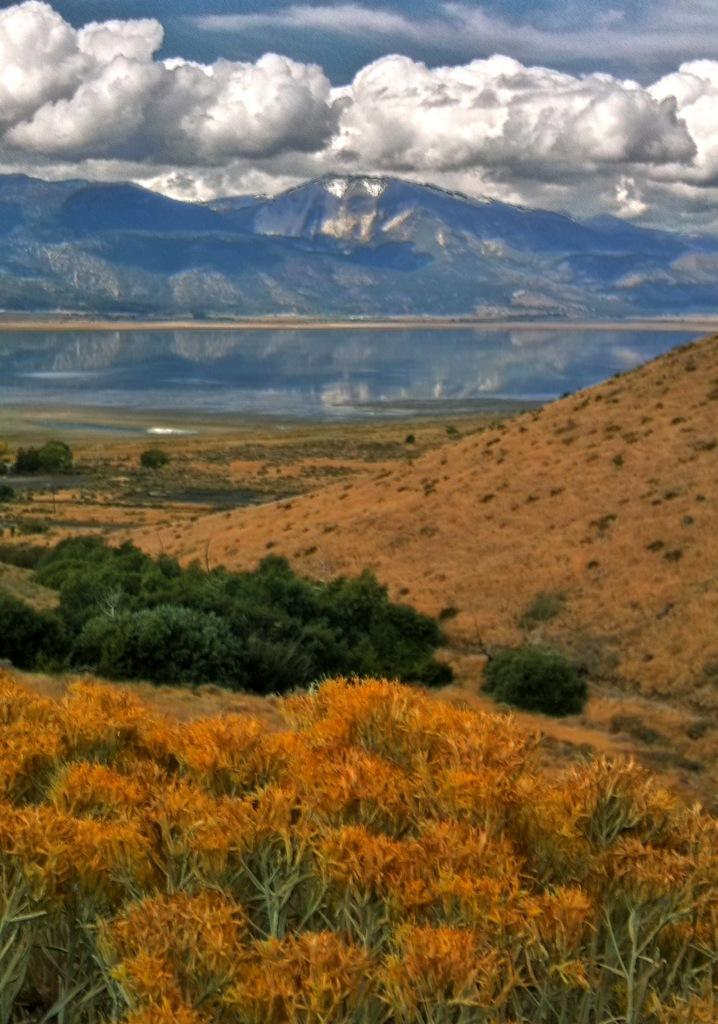What is located in the center of the image? There is water in the center of the image. What type of vegetation is at the bottom of the image? There is grass and bushes at the bottom of the image. What can be seen in the background of the image? There are hills, clouds, and the sky visible in the background of the image. What type of feast is being held in the image? There is no feast present in the image; it features water, grass, bushes, hills, clouds, and the sky. Can you tell me how many dolls are visible in the image? There are no dolls present in the image. 